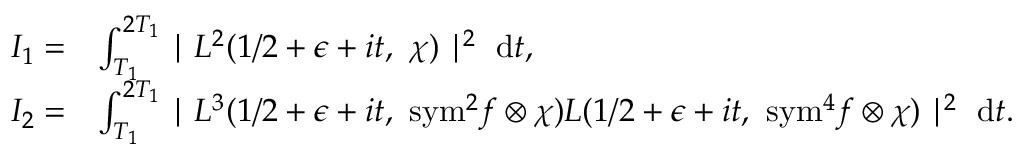Convert formula to latex. <formula><loc_0><loc_0><loc_500><loc_500>\begin{array} { r l } { I _ { 1 } = } & { \int _ { T _ { 1 } } ^ { 2 T _ { 1 } } | L ^ { 2 } ( 1 / 2 + \epsilon + i t , \ \chi ) | ^ { 2 } \ d t , } \\ { I _ { 2 } = } & { \int _ { T _ { 1 } } ^ { 2 T _ { 1 } } | L ^ { 3 } ( 1 / 2 + \epsilon + i t , \ { s y m ^ { 2 } } f \otimes \chi ) L ( 1 / 2 + \epsilon + i t , \ { s y m } ^ { 4 } f \otimes \chi ) | ^ { 2 } \ d t . } \end{array}</formula> 